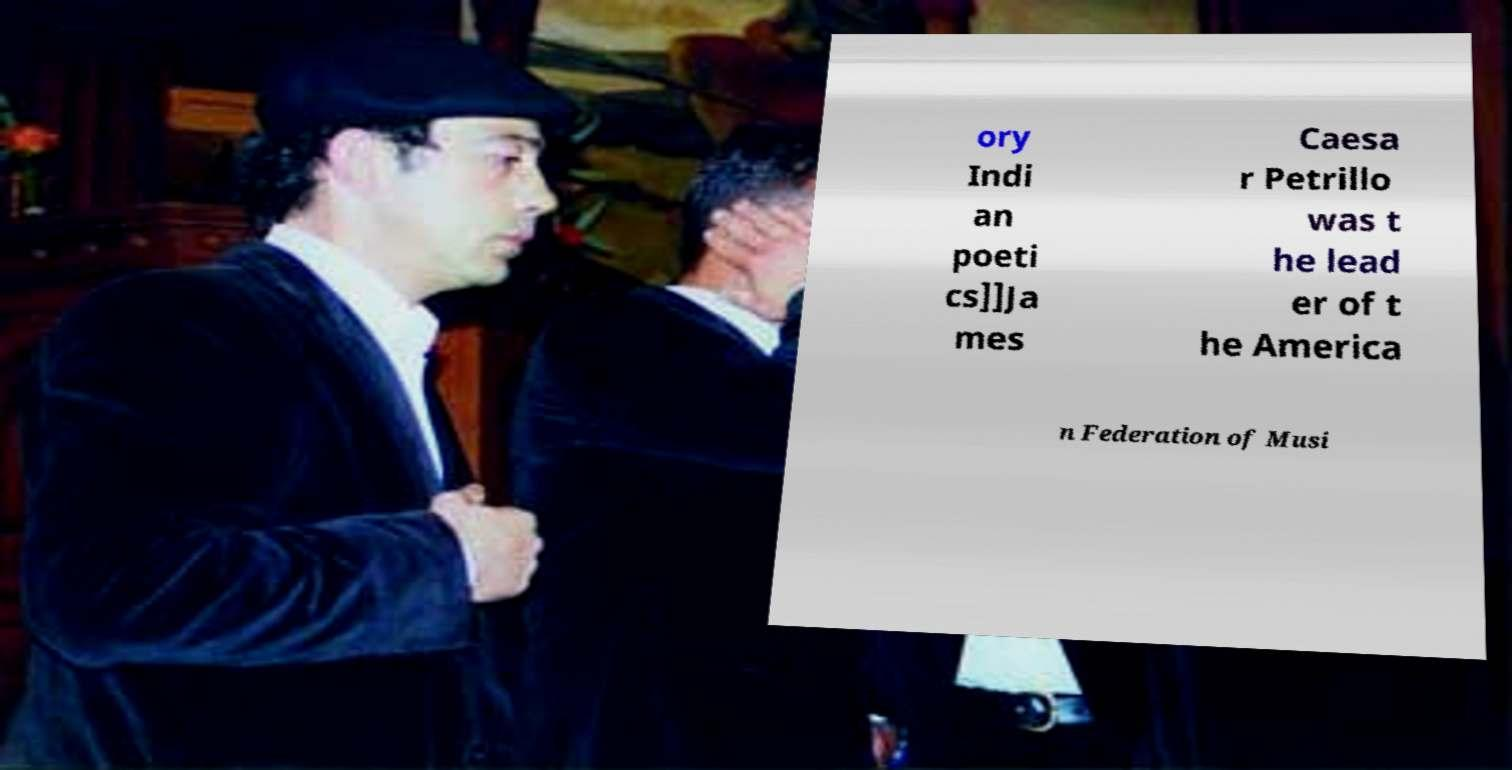What messages or text are displayed in this image? I need them in a readable, typed format. ory Indi an poeti cs]]Ja mes Caesa r Petrillo was t he lead er of t he America n Federation of Musi 